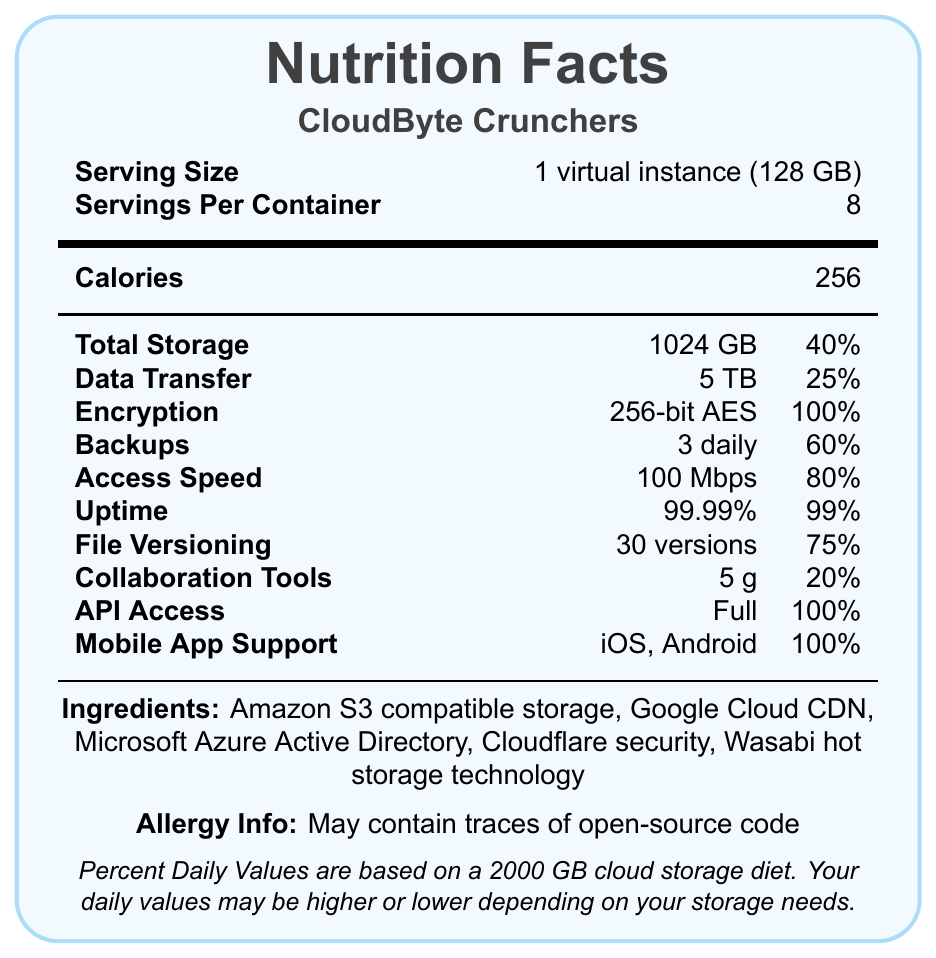what is the serving size for CloudByte Crunchers? The document states that the serving size is "1 virtual instance (128 GB)" in the 'Serving Size' row.
Answer: 1 virtual instance (128 GB) how many servings are there per container? The 'Servings Per Container' row indicates that there are 8 servings per container.
Answer: 8 what is the total storage provided per serving? Total storage is listed as 1024 GB in the 'Total Storage' row under Nutrition Facts.
Answer: 1024 GB what encryption standard is used? The document mentions "256-bit AES" in the 'Encryption' row, indicating the encryption standard used.
Answer: 256-bit AES how much data transfer is allowed per serving? The 'Data Transfer' row notes that 5 TB of data transfer is allowed per serving.
Answer: 5 TB which cloud services are listed as ingredients? These ingredients are listed under the 'Ingredients' section in the document.
Answer: Amazon S3 compatible storage, Google Cloud CDN, Microsoft Azure Active Directory, Cloudflare security, Wasabi hot storage technology what is the daily value percentage for access speed? The 'Access Speed' row lists the daily value percentage as 80%.
Answer: 80% is mobile app support full or partial? Mobile app support is listed as "iOS, Android" with a daily value of 100%, indicating full support.
Answer: Full what percentage of the daily value is provided by uptime? The 'Uptime' row mentions a daily value of 99%.
Answer: 99% how many daily backups are provided? The 'Backups' row states that 3 daily backups are provided.
Answer: 3 daily what is the daily value of collaboration tools? The 'Collaboration Tools' row lists the daily value as 20%.
Answer: 20% does the document indicate if there are any traces of open-source code? The 'Allergy Info' section states "May contain traces of open-source code."
Answer: Yes how many versions are available for file versioning? The 'File Versioning' row notes that 30 versions are available.
Answer: 30 versions identify the main sectors covered in the Nutrition Facts label. A. Storage, Data Transfer, Access Speed B. Storage, Software Compatibility, Customer Support C. Encryption, Collaboration, Mobile App Development D. Backups, Security, Response Time The main sectors covered include Storage, Data Transfer, and Access Speed as listed in the 'Total Storage', 'Data Transfer', and 'Access Speed' rows respectively.
Answer: A which of the following offers full API access? i. CloudByte Crunchers ii. Google Cloud CDN iii. Microsoft Azure Active Directory CloudByte Crunchers offers full API access as per the 'API Access' row of the Nutrition Facts label.
Answer: i. CloudByte Crunchers does the document give information about monthly costs? The document doesn't provide any information about monthly costs, focusing instead on storage specifications and features.
Answer: No provide a summary of the document. The document creatively presents various features and metrics related to a cloud storage solution, formatted to resemble a nutrition facts label, thus providing essential information in an easily digestible format.
Answer: The document is a stylized Nutrition Facts label for a cloud storage provider's virtual snack bar product, CloudByte Crunchers. It details serving size, servings per container, calories, total storage, data transfer, encryption, backups, access speed, uptime, file versioning, collaboration tools, API access, and mobile app support. Also included are ingredients and allergy information. These metrics help users understand the features and capacity of the cloud storage solution relative to a standard daily value. which of the listed features has the highest daily value percentage? Both Encryption and Mobile App Support have a daily value of 100% as indicated in their respective rows.
Answer: Encryption and Mobile App Support (100%) how does the document calculate percent daily values? The disclaimer at the bottom mentions that percent daily values are based on a 2000 GB cloud storage diet.
Answer: Based on a 2000 GB cloud storage diet 